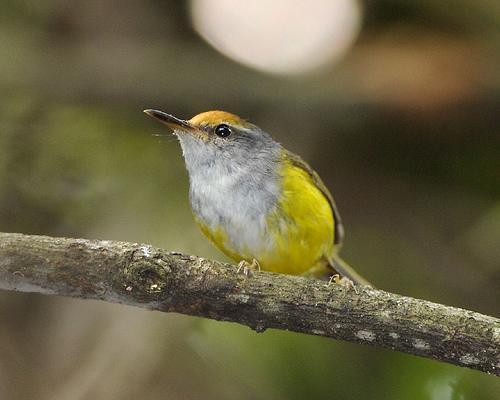How many birds are shown?
Give a very brief answer. 1. 